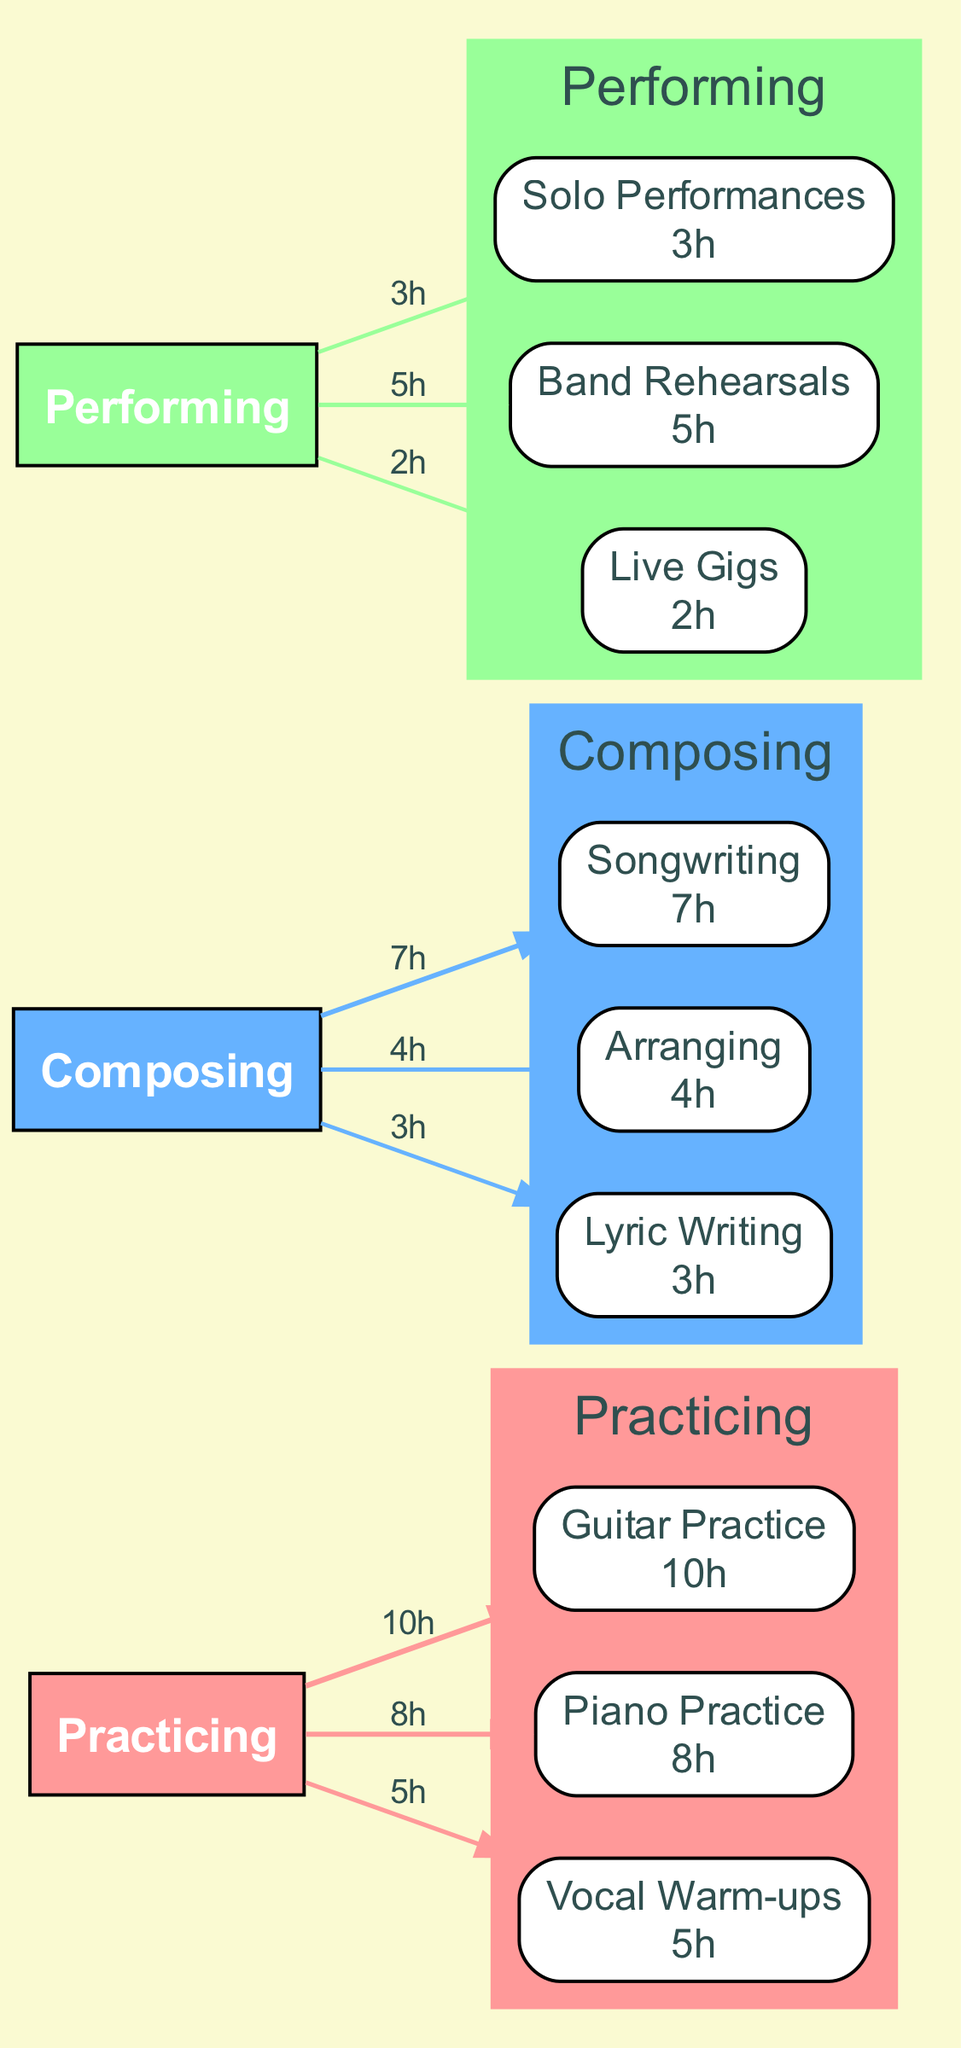What is the total time spent on practicing? To find the total time spent on practicing, I need to sum the time spent on the sub-activities under the "Practicing" category: Guitar Practice (10 hours) + Piano Practice (8 hours) + Vocal Warm-ups (5 hours) = 23 hours.
Answer: 23 hours Which sub-activity had the highest time allocation under Composing? I will look at the sub-activities for Composing: Songwriting (7 hours), Arranging (4 hours), and Lyric Writing (3 hours). Comparing these, Songwriting has the highest time allocation at 7 hours.
Answer: Songwriting How many nodes are there in total in the diagram? The diagram consists of three main activities (Practicing, Composing, Performing) plus three sub-activities for each, resulting in a total of 3 (main nodes) + 9 (sub-nodes) = 12 nodes.
Answer: 12 What is the flow of the highest time spent activity from Practicing to its sub-activities? The highest time spent in Practicing is on Guitar Practice (10 hours). The flow is from the Practicing node to the Guitar Practice sub-node, indicating a strong connection, evident through the thick edge which represents the amount of time.
Answer: Guitar Practice How does the total time spent on Performing compare to Composing? First, I sum the time for Performing: Solo Performances (3 hours) + Band Rehearsals (5 hours) + Live Gigs (2 hours) = 10 hours. Then I sum Composing: Songwriting (7 hours) + Arranging (4 hours) + Lyric Writing (3 hours) = 14 hours. Composing (14 hours) is greater than Performing (10 hours).
Answer: Composing is greater What percentage of total time is spent on Vocal Warm-ups compared to the overall activities? First, I calculate the total time spent on all activities, which is 23 hours (Practicing) + 14 hours (Composing) + 10 hours (Performing) = 47 hours. Vocal Warm-ups occupies 5 hours. The percentage is (5/47)*100, which is approximately 10.64%.
Answer: Approximately ten point six four percent Which main activity has the least overall time spent? I calculate total times for all main activities: Practicing (23 hours), Composing (14 hours), and Performing (10 hours). Performing has the least overall time spent at 10 hours.
Answer: Performing Which activity has the highest total time spent? I compare the total hours spent on each main activity: Practicing (23 hours), Composing (14 hours), and Performing (10 hours). Practicing is the highest at 23 hours.
Answer: Practicing 